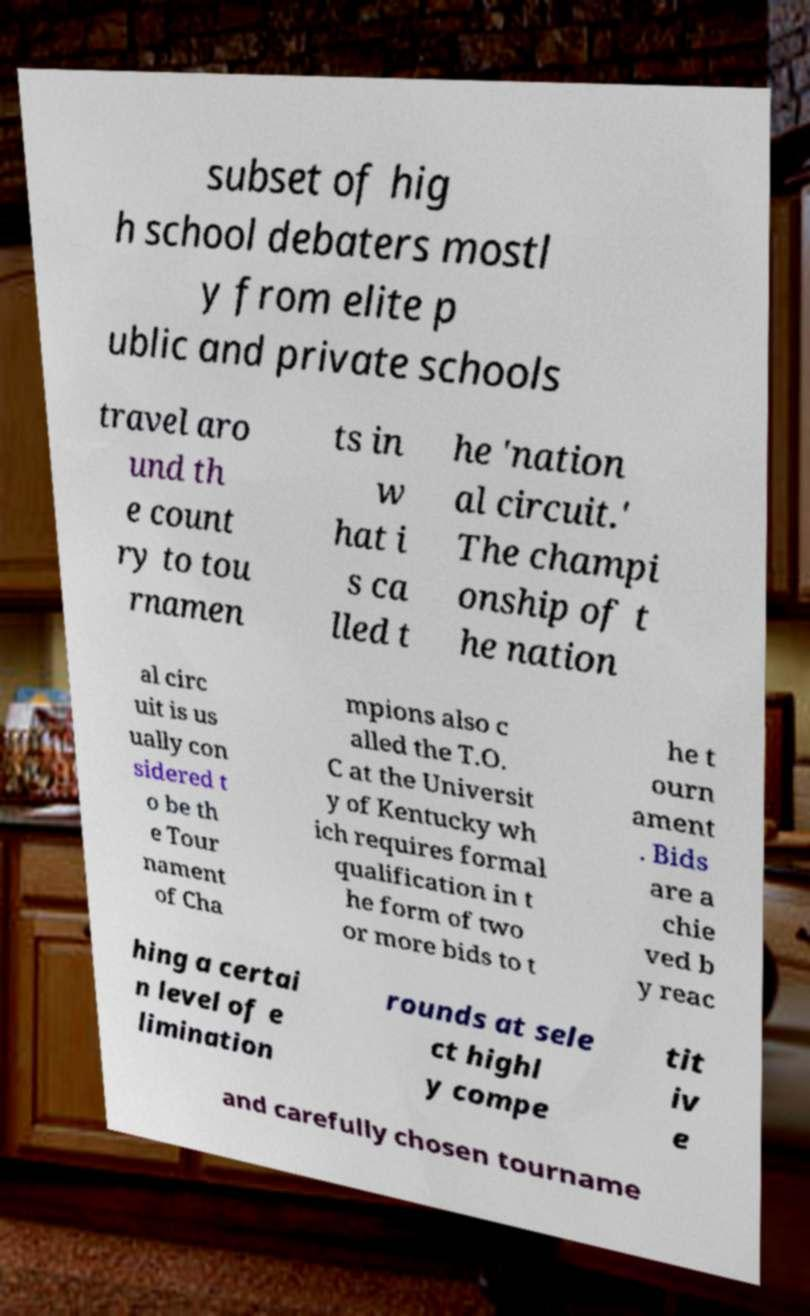There's text embedded in this image that I need extracted. Can you transcribe it verbatim? subset of hig h school debaters mostl y from elite p ublic and private schools travel aro und th e count ry to tou rnamen ts in w hat i s ca lled t he 'nation al circuit.' The champi onship of t he nation al circ uit is us ually con sidered t o be th e Tour nament of Cha mpions also c alled the T.O. C at the Universit y of Kentucky wh ich requires formal qualification in t he form of two or more bids to t he t ourn ament . Bids are a chie ved b y reac hing a certai n level of e limination rounds at sele ct highl y compe tit iv e and carefully chosen tourname 